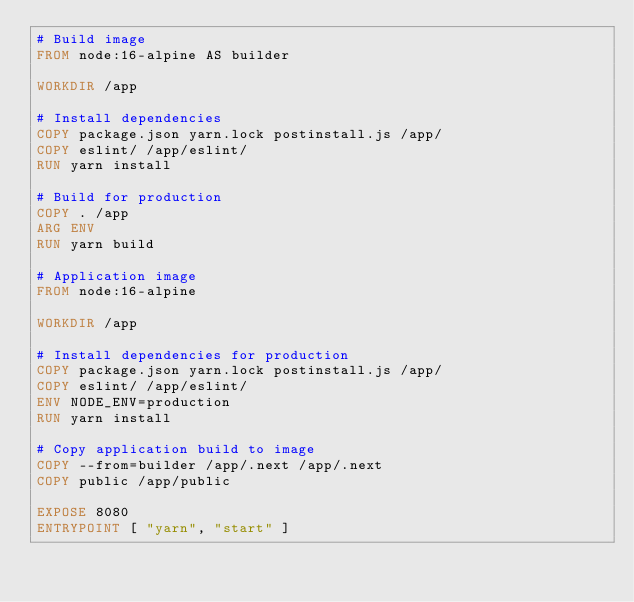<code> <loc_0><loc_0><loc_500><loc_500><_Dockerfile_># Build image
FROM node:16-alpine AS builder

WORKDIR /app

# Install dependencies
COPY package.json yarn.lock postinstall.js /app/
COPY eslint/ /app/eslint/
RUN yarn install

# Build for production
COPY . /app
ARG ENV
RUN yarn build

# Application image
FROM node:16-alpine

WORKDIR /app

# Install dependencies for production
COPY package.json yarn.lock postinstall.js /app/
COPY eslint/ /app/eslint/
ENV NODE_ENV=production
RUN yarn install

# Copy application build to image
COPY --from=builder /app/.next /app/.next
COPY public /app/public

EXPOSE 8080
ENTRYPOINT [ "yarn", "start" ]
</code> 